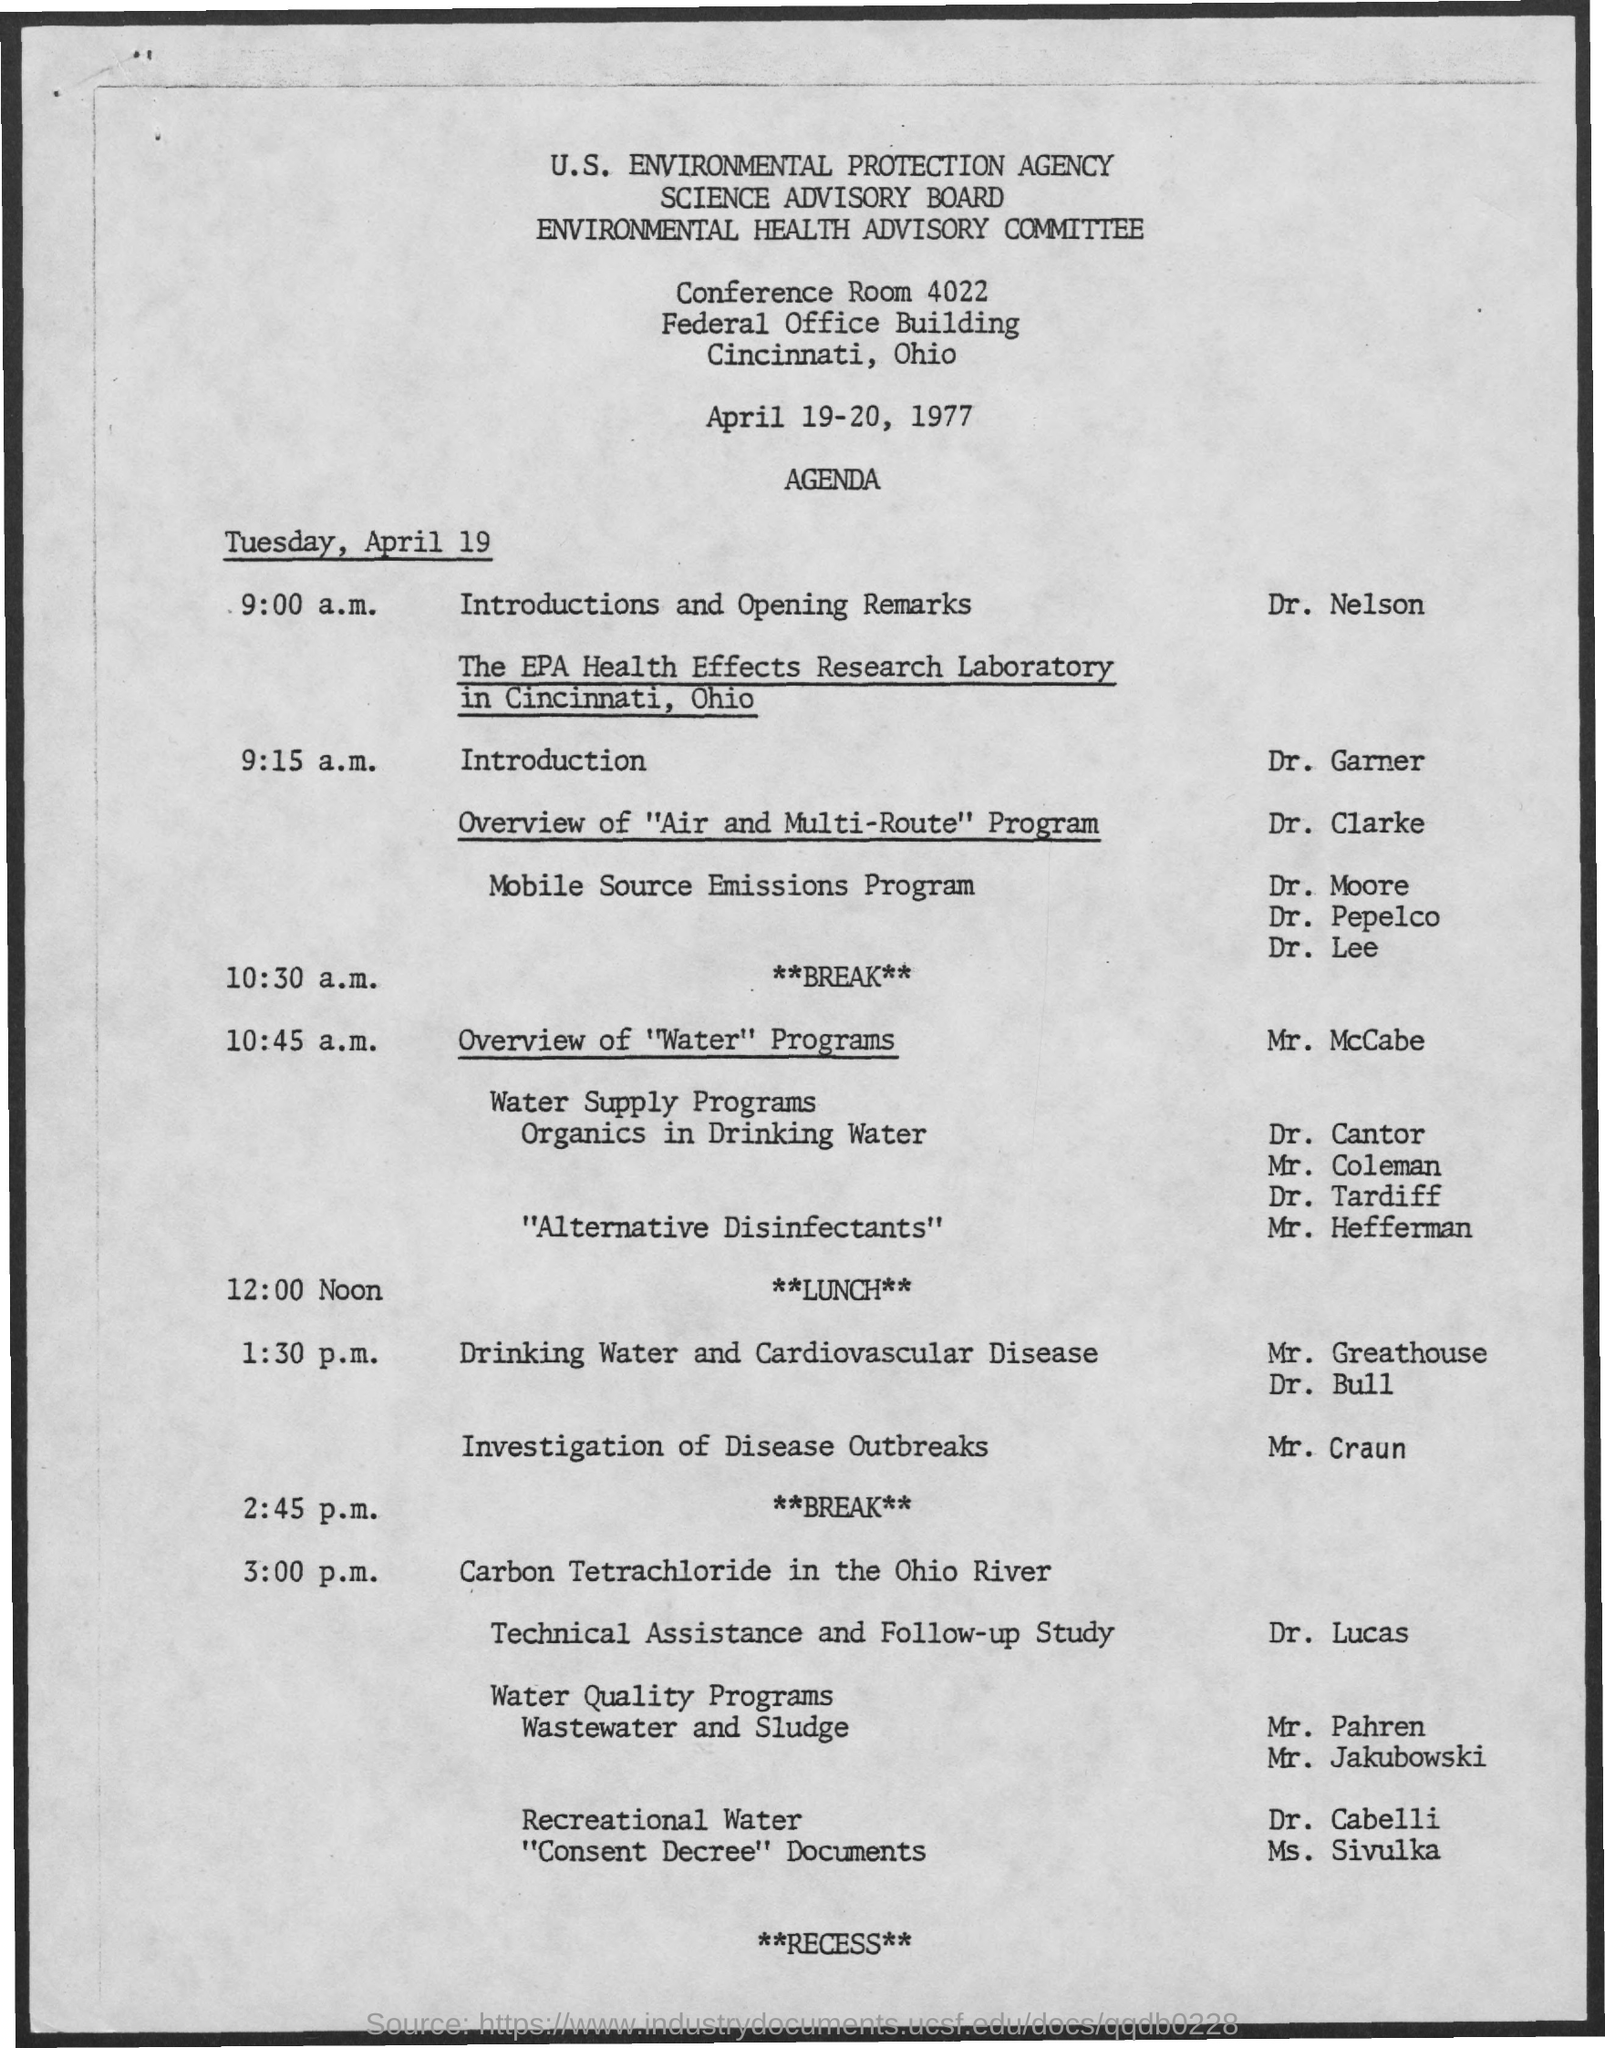Who is presenting Introduction and opening remarks?
Your answer should be very brief. Dr. Nelson. 